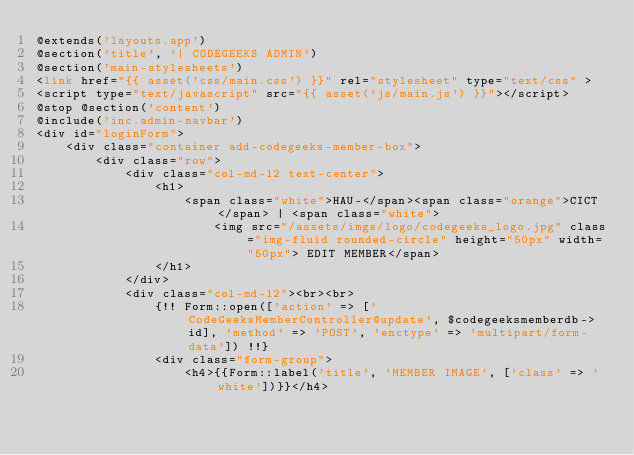<code> <loc_0><loc_0><loc_500><loc_500><_PHP_>@extends('layouts.app') 
@section('title', '| CODEGEEKS ADMIN') 
@section('main-stylesheets')
<link href="{{ asset('css/main.css') }}" rel="stylesheet" type="text/css" >    
<script type="text/javascript" src="{{ asset('js/main.js') }}"></script>     
@stop @section('content') 
@include('inc.admin-navbar')
<div id="loginForm">
    <div class="container add-codegeeks-member-box">
        <div class="row">
            <div class="col-md-12 text-center">
                <h1>
                    <span class="white">HAU-</span><span class="orange">CICT</span> | <span class="white">
                        <img src="/assets/imgs/logo/codegeeks_logo.jpg" class="img-fluid rounded-circle" height="50px" width="50px"> EDIT MEMBER</span>
                </h1>
            </div>
            <div class="col-md-12"><br><br>
                {!! Form::open(['action' => ['CodeGeeksMemberController@update', $codegeeksmemberdb->id], 'method' => 'POST', 'enctype' => 'multipart/form-data']) !!}
                <div class="form-group">
                    <h4>{{Form::label('title', 'MEMBER IMAGE', ['class' => 'white'])}}</h4></code> 